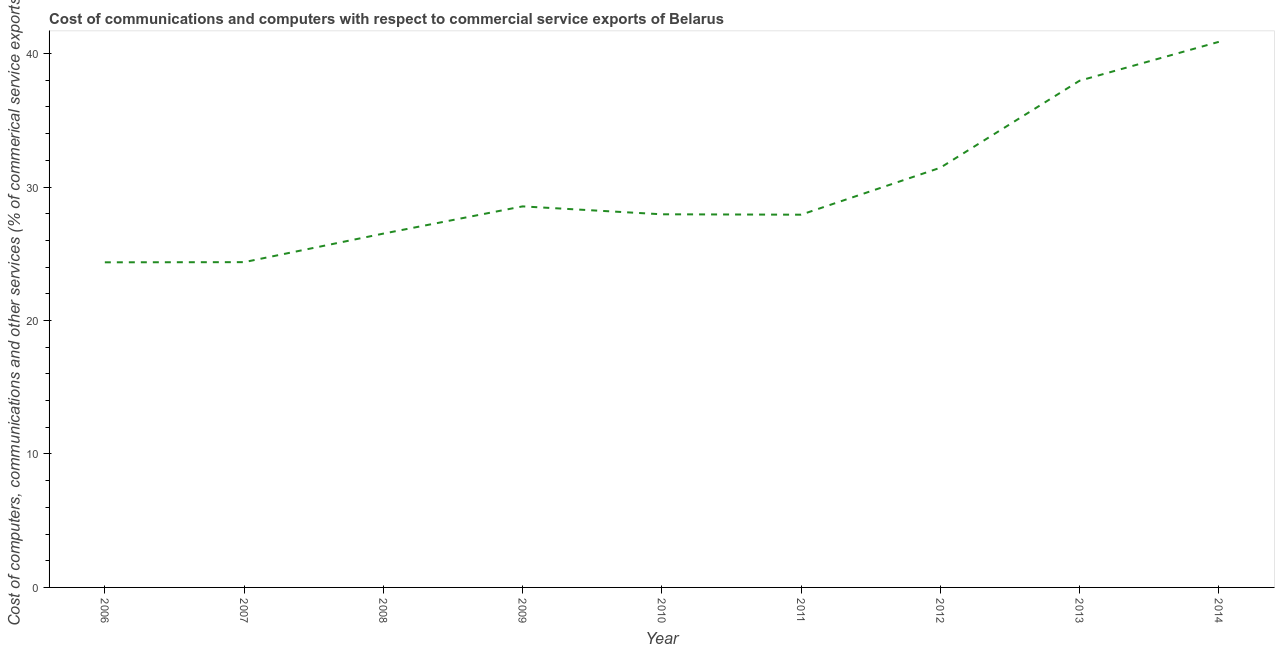What is the  computer and other services in 2012?
Offer a very short reply. 31.45. Across all years, what is the maximum cost of communications?
Your response must be concise. 40.88. Across all years, what is the minimum  computer and other services?
Your answer should be very brief. 24.36. What is the sum of the  computer and other services?
Give a very brief answer. 269.96. What is the difference between the  computer and other services in 2006 and 2009?
Your answer should be compact. -4.19. What is the average  computer and other services per year?
Your response must be concise. 30. What is the median  computer and other services?
Give a very brief answer. 27.96. In how many years, is the  computer and other services greater than 30 %?
Your answer should be compact. 3. Do a majority of the years between 2006 and 2007 (inclusive) have  computer and other services greater than 24 %?
Offer a terse response. Yes. What is the ratio of the  computer and other services in 2011 to that in 2013?
Ensure brevity in your answer.  0.74. Is the  computer and other services in 2011 less than that in 2013?
Your answer should be very brief. Yes. What is the difference between the highest and the second highest  computer and other services?
Keep it short and to the point. 2.91. Is the sum of the cost of communications in 2006 and 2010 greater than the maximum cost of communications across all years?
Offer a very short reply. Yes. What is the difference between the highest and the lowest cost of communications?
Make the answer very short. 16.52. In how many years, is the cost of communications greater than the average cost of communications taken over all years?
Make the answer very short. 3. How many lines are there?
Provide a short and direct response. 1. How many years are there in the graph?
Give a very brief answer. 9. What is the difference between two consecutive major ticks on the Y-axis?
Your answer should be compact. 10. Are the values on the major ticks of Y-axis written in scientific E-notation?
Offer a very short reply. No. Does the graph contain any zero values?
Keep it short and to the point. No. Does the graph contain grids?
Provide a short and direct response. No. What is the title of the graph?
Your answer should be very brief. Cost of communications and computers with respect to commercial service exports of Belarus. What is the label or title of the Y-axis?
Your response must be concise. Cost of computers, communications and other services (% of commerical service exports). What is the Cost of computers, communications and other services (% of commerical service exports) in 2006?
Provide a succinct answer. 24.36. What is the Cost of computers, communications and other services (% of commerical service exports) of 2007?
Offer a very short reply. 24.37. What is the Cost of computers, communications and other services (% of commerical service exports) of 2008?
Ensure brevity in your answer.  26.51. What is the Cost of computers, communications and other services (% of commerical service exports) in 2009?
Keep it short and to the point. 28.55. What is the Cost of computers, communications and other services (% of commerical service exports) of 2010?
Your answer should be very brief. 27.96. What is the Cost of computers, communications and other services (% of commerical service exports) of 2011?
Offer a very short reply. 27.93. What is the Cost of computers, communications and other services (% of commerical service exports) in 2012?
Your response must be concise. 31.45. What is the Cost of computers, communications and other services (% of commerical service exports) of 2013?
Make the answer very short. 37.97. What is the Cost of computers, communications and other services (% of commerical service exports) in 2014?
Provide a short and direct response. 40.88. What is the difference between the Cost of computers, communications and other services (% of commerical service exports) in 2006 and 2007?
Provide a succinct answer. -0.01. What is the difference between the Cost of computers, communications and other services (% of commerical service exports) in 2006 and 2008?
Give a very brief answer. -2.15. What is the difference between the Cost of computers, communications and other services (% of commerical service exports) in 2006 and 2009?
Offer a terse response. -4.19. What is the difference between the Cost of computers, communications and other services (% of commerical service exports) in 2006 and 2010?
Offer a very short reply. -3.6. What is the difference between the Cost of computers, communications and other services (% of commerical service exports) in 2006 and 2011?
Make the answer very short. -3.57. What is the difference between the Cost of computers, communications and other services (% of commerical service exports) in 2006 and 2012?
Give a very brief answer. -7.09. What is the difference between the Cost of computers, communications and other services (% of commerical service exports) in 2006 and 2013?
Ensure brevity in your answer.  -13.61. What is the difference between the Cost of computers, communications and other services (% of commerical service exports) in 2006 and 2014?
Offer a terse response. -16.52. What is the difference between the Cost of computers, communications and other services (% of commerical service exports) in 2007 and 2008?
Your answer should be compact. -2.14. What is the difference between the Cost of computers, communications and other services (% of commerical service exports) in 2007 and 2009?
Your answer should be compact. -4.18. What is the difference between the Cost of computers, communications and other services (% of commerical service exports) in 2007 and 2010?
Provide a succinct answer. -3.59. What is the difference between the Cost of computers, communications and other services (% of commerical service exports) in 2007 and 2011?
Provide a succinct answer. -3.56. What is the difference between the Cost of computers, communications and other services (% of commerical service exports) in 2007 and 2012?
Your answer should be compact. -7.07. What is the difference between the Cost of computers, communications and other services (% of commerical service exports) in 2007 and 2013?
Give a very brief answer. -13.59. What is the difference between the Cost of computers, communications and other services (% of commerical service exports) in 2007 and 2014?
Give a very brief answer. -16.51. What is the difference between the Cost of computers, communications and other services (% of commerical service exports) in 2008 and 2009?
Keep it short and to the point. -2.04. What is the difference between the Cost of computers, communications and other services (% of commerical service exports) in 2008 and 2010?
Ensure brevity in your answer.  -1.45. What is the difference between the Cost of computers, communications and other services (% of commerical service exports) in 2008 and 2011?
Your answer should be compact. -1.42. What is the difference between the Cost of computers, communications and other services (% of commerical service exports) in 2008 and 2012?
Offer a terse response. -4.94. What is the difference between the Cost of computers, communications and other services (% of commerical service exports) in 2008 and 2013?
Your answer should be very brief. -11.46. What is the difference between the Cost of computers, communications and other services (% of commerical service exports) in 2008 and 2014?
Keep it short and to the point. -14.37. What is the difference between the Cost of computers, communications and other services (% of commerical service exports) in 2009 and 2010?
Your answer should be compact. 0.59. What is the difference between the Cost of computers, communications and other services (% of commerical service exports) in 2009 and 2011?
Provide a short and direct response. 0.62. What is the difference between the Cost of computers, communications and other services (% of commerical service exports) in 2009 and 2012?
Ensure brevity in your answer.  -2.9. What is the difference between the Cost of computers, communications and other services (% of commerical service exports) in 2009 and 2013?
Give a very brief answer. -9.42. What is the difference between the Cost of computers, communications and other services (% of commerical service exports) in 2009 and 2014?
Give a very brief answer. -12.33. What is the difference between the Cost of computers, communications and other services (% of commerical service exports) in 2010 and 2011?
Give a very brief answer. 0.03. What is the difference between the Cost of computers, communications and other services (% of commerical service exports) in 2010 and 2012?
Provide a short and direct response. -3.49. What is the difference between the Cost of computers, communications and other services (% of commerical service exports) in 2010 and 2013?
Your answer should be compact. -10.01. What is the difference between the Cost of computers, communications and other services (% of commerical service exports) in 2010 and 2014?
Keep it short and to the point. -12.92. What is the difference between the Cost of computers, communications and other services (% of commerical service exports) in 2011 and 2012?
Provide a short and direct response. -3.52. What is the difference between the Cost of computers, communications and other services (% of commerical service exports) in 2011 and 2013?
Give a very brief answer. -10.04. What is the difference between the Cost of computers, communications and other services (% of commerical service exports) in 2011 and 2014?
Provide a short and direct response. -12.95. What is the difference between the Cost of computers, communications and other services (% of commerical service exports) in 2012 and 2013?
Offer a very short reply. -6.52. What is the difference between the Cost of computers, communications and other services (% of commerical service exports) in 2012 and 2014?
Offer a very short reply. -9.43. What is the difference between the Cost of computers, communications and other services (% of commerical service exports) in 2013 and 2014?
Provide a short and direct response. -2.91. What is the ratio of the Cost of computers, communications and other services (% of commerical service exports) in 2006 to that in 2007?
Give a very brief answer. 1. What is the ratio of the Cost of computers, communications and other services (% of commerical service exports) in 2006 to that in 2008?
Your answer should be very brief. 0.92. What is the ratio of the Cost of computers, communications and other services (% of commerical service exports) in 2006 to that in 2009?
Offer a very short reply. 0.85. What is the ratio of the Cost of computers, communications and other services (% of commerical service exports) in 2006 to that in 2010?
Ensure brevity in your answer.  0.87. What is the ratio of the Cost of computers, communications and other services (% of commerical service exports) in 2006 to that in 2011?
Give a very brief answer. 0.87. What is the ratio of the Cost of computers, communications and other services (% of commerical service exports) in 2006 to that in 2012?
Ensure brevity in your answer.  0.78. What is the ratio of the Cost of computers, communications and other services (% of commerical service exports) in 2006 to that in 2013?
Your answer should be very brief. 0.64. What is the ratio of the Cost of computers, communications and other services (% of commerical service exports) in 2006 to that in 2014?
Your answer should be very brief. 0.6. What is the ratio of the Cost of computers, communications and other services (% of commerical service exports) in 2007 to that in 2008?
Give a very brief answer. 0.92. What is the ratio of the Cost of computers, communications and other services (% of commerical service exports) in 2007 to that in 2009?
Your answer should be very brief. 0.85. What is the ratio of the Cost of computers, communications and other services (% of commerical service exports) in 2007 to that in 2010?
Offer a very short reply. 0.87. What is the ratio of the Cost of computers, communications and other services (% of commerical service exports) in 2007 to that in 2011?
Offer a very short reply. 0.87. What is the ratio of the Cost of computers, communications and other services (% of commerical service exports) in 2007 to that in 2012?
Ensure brevity in your answer.  0.78. What is the ratio of the Cost of computers, communications and other services (% of commerical service exports) in 2007 to that in 2013?
Offer a very short reply. 0.64. What is the ratio of the Cost of computers, communications and other services (% of commerical service exports) in 2007 to that in 2014?
Give a very brief answer. 0.6. What is the ratio of the Cost of computers, communications and other services (% of commerical service exports) in 2008 to that in 2009?
Your answer should be very brief. 0.93. What is the ratio of the Cost of computers, communications and other services (% of commerical service exports) in 2008 to that in 2010?
Make the answer very short. 0.95. What is the ratio of the Cost of computers, communications and other services (% of commerical service exports) in 2008 to that in 2011?
Your answer should be very brief. 0.95. What is the ratio of the Cost of computers, communications and other services (% of commerical service exports) in 2008 to that in 2012?
Give a very brief answer. 0.84. What is the ratio of the Cost of computers, communications and other services (% of commerical service exports) in 2008 to that in 2013?
Give a very brief answer. 0.7. What is the ratio of the Cost of computers, communications and other services (% of commerical service exports) in 2008 to that in 2014?
Give a very brief answer. 0.65. What is the ratio of the Cost of computers, communications and other services (% of commerical service exports) in 2009 to that in 2012?
Make the answer very short. 0.91. What is the ratio of the Cost of computers, communications and other services (% of commerical service exports) in 2009 to that in 2013?
Ensure brevity in your answer.  0.75. What is the ratio of the Cost of computers, communications and other services (% of commerical service exports) in 2009 to that in 2014?
Provide a succinct answer. 0.7. What is the ratio of the Cost of computers, communications and other services (% of commerical service exports) in 2010 to that in 2011?
Your answer should be very brief. 1. What is the ratio of the Cost of computers, communications and other services (% of commerical service exports) in 2010 to that in 2012?
Offer a very short reply. 0.89. What is the ratio of the Cost of computers, communications and other services (% of commerical service exports) in 2010 to that in 2013?
Ensure brevity in your answer.  0.74. What is the ratio of the Cost of computers, communications and other services (% of commerical service exports) in 2010 to that in 2014?
Make the answer very short. 0.68. What is the ratio of the Cost of computers, communications and other services (% of commerical service exports) in 2011 to that in 2012?
Offer a terse response. 0.89. What is the ratio of the Cost of computers, communications and other services (% of commerical service exports) in 2011 to that in 2013?
Provide a succinct answer. 0.74. What is the ratio of the Cost of computers, communications and other services (% of commerical service exports) in 2011 to that in 2014?
Ensure brevity in your answer.  0.68. What is the ratio of the Cost of computers, communications and other services (% of commerical service exports) in 2012 to that in 2013?
Your answer should be compact. 0.83. What is the ratio of the Cost of computers, communications and other services (% of commerical service exports) in 2012 to that in 2014?
Provide a short and direct response. 0.77. What is the ratio of the Cost of computers, communications and other services (% of commerical service exports) in 2013 to that in 2014?
Make the answer very short. 0.93. 